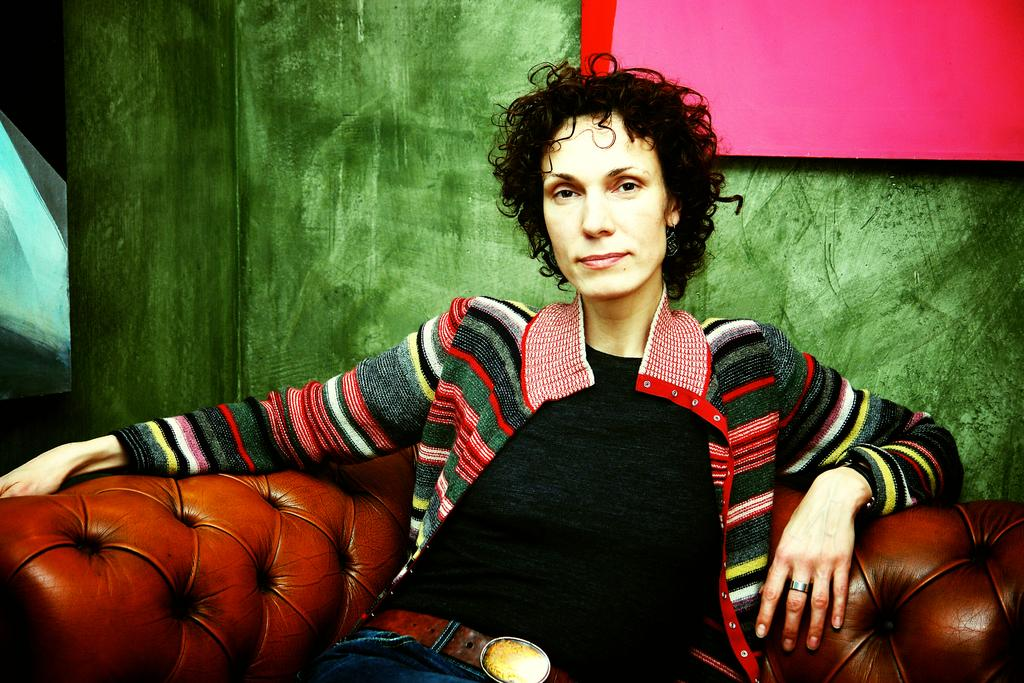Who is present in the image? There is a woman in the image. What is the woman doing in the image? The woman is sitting on a sofa. What is the woman wearing in the image? The woman is wearing a sweater, a black t-shirt, and jeans. What can be seen in the background of the image? There is a wall with a frame in the background of the image. What type of rake is the woman using to clean the floor in the image? There is no rake present in the image, and the woman is not cleaning the floor. What type of lipstick is the woman wearing in the image? The image does not show the woman wearing lipstick, so we cannot determine the type of lipstick. 